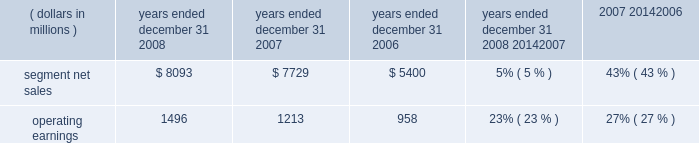The segment had operating earnings of $ 709 million in 2007 , compared to operating earnings of $ 787 million in 2006 .
The decrease in operating earnings was primarily due to a decrease in gross margin , driven by : ( i ) lower net sales of iden infrastructure equipment , and ( ii ) continued competitive pricing pressure in the market for gsm infrastructure equipment , partially offset by : ( i ) increased net sales of digital entertainment devices , and ( ii ) the reversal of reorganization of business accruals recorded in 2006 relating to employee severance which were no longer needed .
Sg&a expenses increased primarily due to the expenses from recently acquired businesses , partially offset by savings from cost-reduction initiatives .
R&d expenditures decreased primarily due to savings from cost- reduction initiatives , partially offset by expenditures by recently acquired businesses and continued investment in digital entertainment devices and wimax .
As a percentage of net sales in 2007 as compared to 2006 , gross margin , sg&a expenses , r&d expenditures and operating margin all decreased .
In 2007 , sales to the segment 2019s top five customers represented approximately 43% ( 43 % ) of the segment 2019s net sales .
The segment 2019s backlog was $ 2.6 billion at december 31 , 2007 , compared to $ 3.2 billion at december 31 , 2006 .
In the home business , demand for the segment 2019s products depends primarily on the level of capital spending by broadband operators for constructing , rebuilding or upgrading their communications systems , and for offering advanced services .
During the second quarter of 2007 , the segment began shipping digital set-tops that support the federal communications commission ( 201cfcc 201d ) 2014 mandated separable security requirement .
Fcc regulations mandating the separation of security functionality from set-tops went into effect on july 1 , 2007 .
As a result of these regulations , many cable service providers accelerated their purchases of set-tops in the first half of 2007 .
Additionally , in 2007 , our digital video customers significantly increased their purchases of the segment 2019s products and services , primarily due to increased demand for digital entertainment devices , particularly hd/dvr devices .
During 2007 , the segment completed the acquisitions of : ( i ) netopia , inc. , a broadband equipment provider for dsl customers , which allows for phone , tv and fast internet connections , ( ii ) tut systems , inc. , a leading developer of edge routing and video encoders , ( iii ) modulus video , inc. , a provider of mpeg-4 advanced coding compression systems designed for delivery of high-value video content in ip set-top devices for the digital video , broadcast and satellite marketplaces , ( iv ) terayon communication systems , inc. , a provider of real-time digital video networking applications to cable , satellite and telecommunication service providers worldwide , and ( v ) leapstone systems , inc. , a provider of intelligent multimedia service delivery and content management applications to networks operators .
These acquisitions enhance our ability to provide complete end-to-end systems for the delivery of advanced video , voice and data services .
In december 2007 , motorola completed the sale of ecc to emerson for $ 346 million in cash .
Enterprise mobility solutions segment the enterprise mobility solutions segment designs , manufactures , sells , installs and services analog and digital two-way radio , voice and data communications products and systems for private networks , wireless broadband systems and end-to-end enterprise mobility solutions to a wide range of enterprise markets , including government and public safety agencies ( which , together with all sales to distributors of two-way communication products , are referred to as the 201cgovernment and public safety market 201d ) , as well as retail , energy and utilities , transportation , manufacturing , healthcare and other commercial customers ( which , collectively , are referred to as the 201ccommercial enterprise market 201d ) .
In 2008 , the segment 2019s net sales represented 27% ( 27 % ) of the company 2019s consolidated net sales , compared to 21% ( 21 % ) in 2007 and 13% ( 13 % ) in 2006 .
( dollars in millions ) 2008 2007 2006 2008 20142007 2007 20142006 years ended december 31 percent change .
Segment results 20142008 compared to 2007 in 2008 , the segment 2019s net sales increased 5% ( 5 % ) to $ 8.1 billion , compared to $ 7.7 billion in 2007 .
The 5% ( 5 % ) increase in net sales reflects an 8% ( 8 % ) increase in net sales to the government and public safety market , partially offset by a 2% ( 2 % ) decrease in net sales to the commercial enterprise market .
The increase in net sales to the government and public safety market was primarily driven by : ( i ) increased net sales outside of north america , and ( ii ) the net sales generated by vertex standard co. , ltd. , a business the company acquired a controlling interest of in january 2008 , partially offset by lower net sales in north america .
On a geographic basis , the segment 2019s net sales were higher in emea , asia and latin america and lower in north america .
65management 2019s discussion and analysis of financial condition and results of operations %%transmsg*** transmitting job : c49054 pcn : 068000000 ***%%pcmsg|65 |00024|yes|no|02/24/2009 12:31|0|0|page is valid , no graphics -- color : n| .
What was the ratio of the segment net sales in 2008 to 2006? 
Computations: (8093 / 5400)
Answer: 1.4987. 